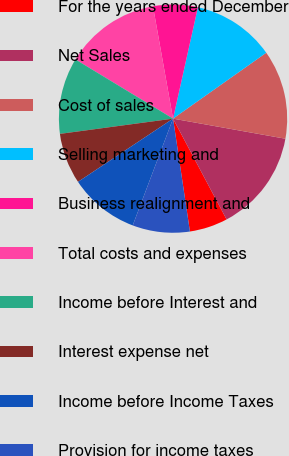<chart> <loc_0><loc_0><loc_500><loc_500><pie_chart><fcel>For the years ended December<fcel>Net Sales<fcel>Cost of sales<fcel>Selling marketing and<fcel>Business realignment and<fcel>Total costs and expenses<fcel>Income before Interest and<fcel>Interest expense net<fcel>Income before Income Taxes<fcel>Provision for income taxes<nl><fcel>5.41%<fcel>14.41%<fcel>12.61%<fcel>11.71%<fcel>6.31%<fcel>13.51%<fcel>10.81%<fcel>7.21%<fcel>9.91%<fcel>8.11%<nl></chart> 